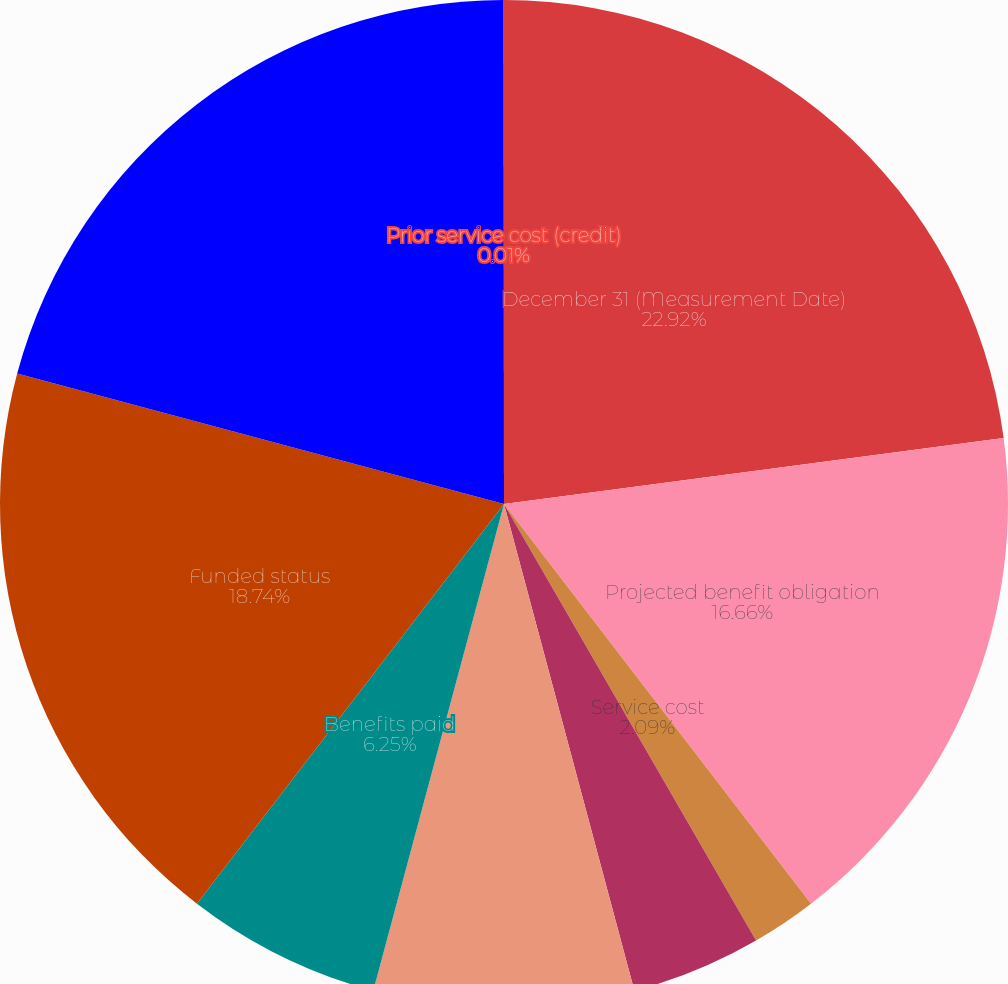<chart> <loc_0><loc_0><loc_500><loc_500><pie_chart><fcel>December 31 (Measurement Date)<fcel>Projected benefit obligation<fcel>Service cost<fcel>Interest cost<fcel>Actuarial (gains)/losses and<fcel>Benefits paid<fcel>Funded status<fcel>Net amount recognized on the<fcel>Prior service cost (credit)<nl><fcel>22.91%<fcel>16.66%<fcel>2.09%<fcel>4.17%<fcel>8.34%<fcel>6.25%<fcel>18.74%<fcel>20.82%<fcel>0.01%<nl></chart> 